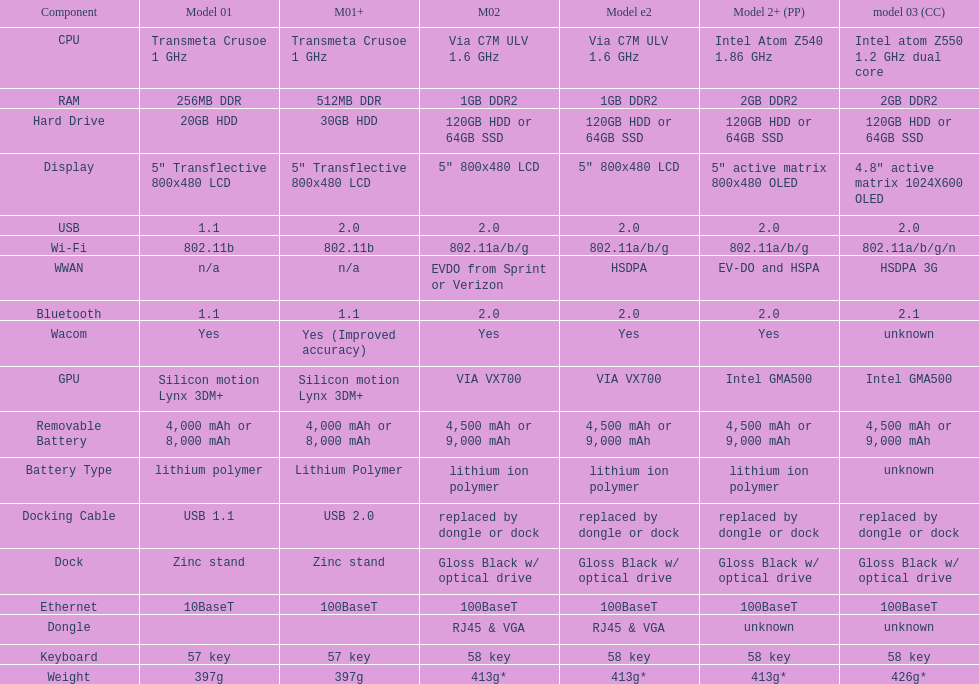How much more weight does the model 3 have over model 1? 29g. 